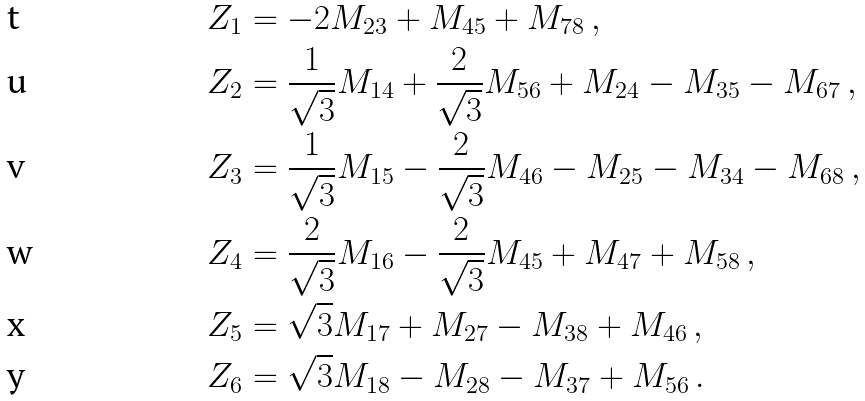Convert formula to latex. <formula><loc_0><loc_0><loc_500><loc_500>Z _ { 1 } & = - 2 M _ { 2 3 } + M _ { 4 5 } + M _ { 7 8 } \, , \\ Z _ { 2 } & = \frac { 1 } { \sqrt { 3 } } M _ { 1 4 } + \frac { 2 } { \sqrt { 3 } } M _ { 5 6 } + M _ { 2 4 } - M _ { 3 5 } - M _ { 6 7 } \, , \\ Z _ { 3 } & = \frac { 1 } { \sqrt { 3 } } M _ { 1 5 } - \frac { 2 } { \sqrt { 3 } } M _ { 4 6 } - M _ { 2 5 } - M _ { 3 4 } - M _ { 6 8 } \, , \\ Z _ { 4 } & = \frac { 2 } { \sqrt { 3 } } M _ { 1 6 } - \frac { 2 } { \sqrt { 3 } } M _ { 4 5 } + M _ { 4 7 } + M _ { 5 8 } \, , \\ Z _ { 5 } & = \sqrt { 3 } M _ { 1 7 } + M _ { 2 7 } - M _ { 3 8 } + M _ { 4 6 } \, , \\ Z _ { 6 } & = \sqrt { 3 } M _ { 1 8 } - M _ { 2 8 } - M _ { 3 7 } + M _ { 5 6 } \, .</formula> 